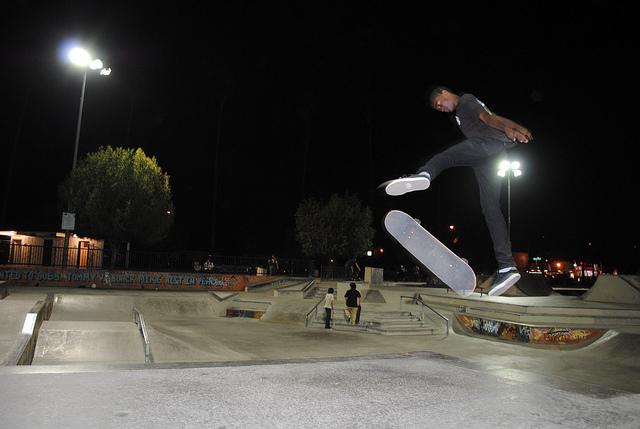Is the skateboarding touching his board in the photo?
Write a very short answer. No. Is he in a parking lot?
Concise answer only. No. Does the bottom of his shoes have cleats?
Quick response, please. No. Is he a professional?
Be succinct. No. 